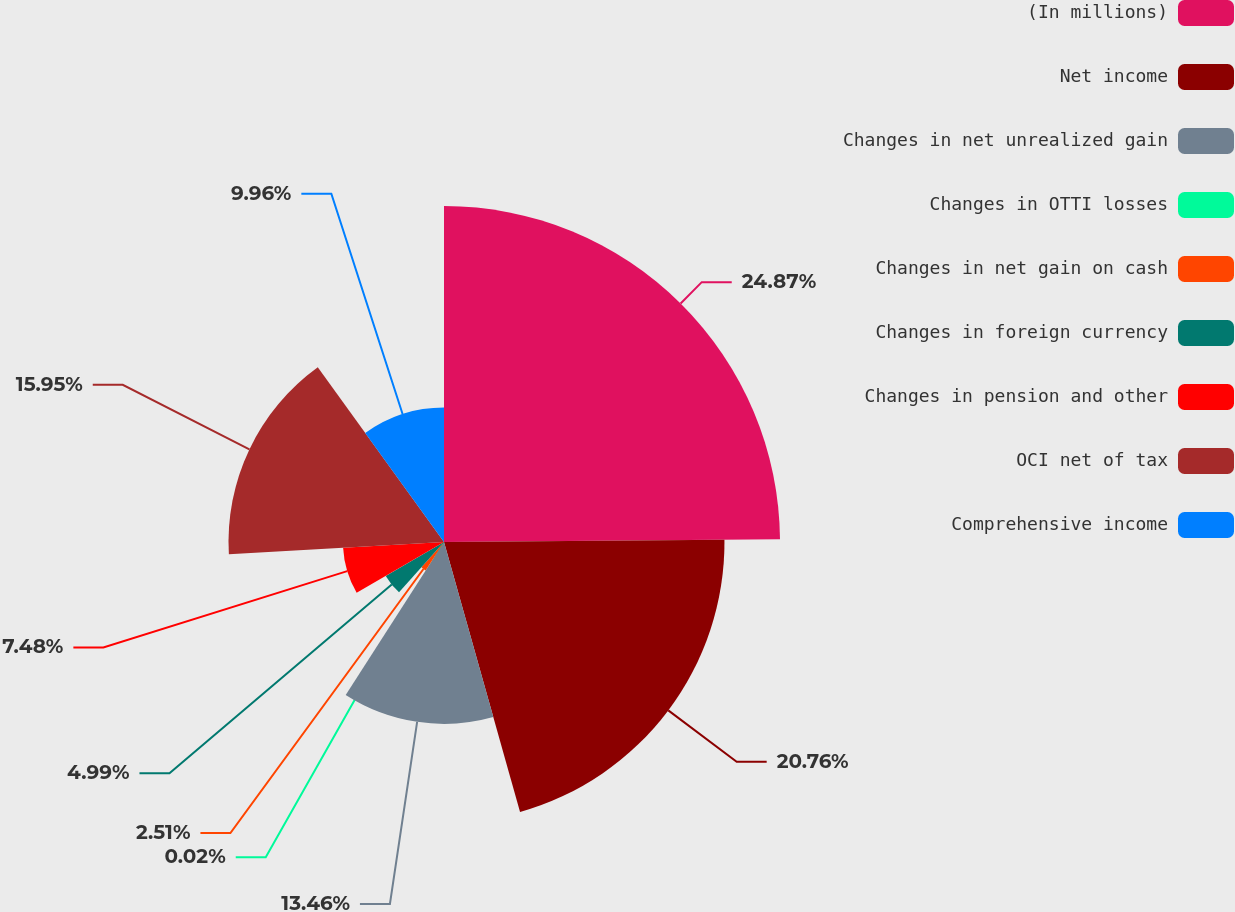<chart> <loc_0><loc_0><loc_500><loc_500><pie_chart><fcel>(In millions)<fcel>Net income<fcel>Changes in net unrealized gain<fcel>Changes in OTTI losses<fcel>Changes in net gain on cash<fcel>Changes in foreign currency<fcel>Changes in pension and other<fcel>OCI net of tax<fcel>Comprehensive income<nl><fcel>24.87%<fcel>20.76%<fcel>13.46%<fcel>0.02%<fcel>2.51%<fcel>4.99%<fcel>7.48%<fcel>15.95%<fcel>9.96%<nl></chart> 